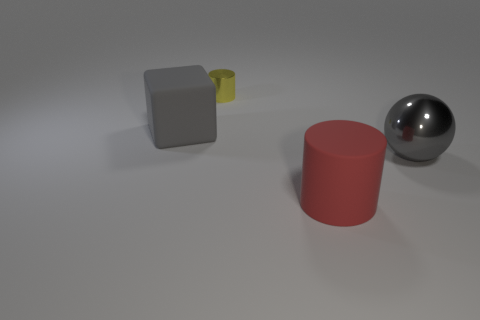Add 4 yellow shiny things. How many objects exist? 8 Subtract all cubes. How many objects are left? 3 Subtract 0 brown cubes. How many objects are left? 4 Subtract all brown cylinders. Subtract all purple blocks. How many cylinders are left? 2 Subtract all gray rubber cubes. Subtract all gray spheres. How many objects are left? 2 Add 2 red cylinders. How many red cylinders are left? 3 Add 1 large blue rubber cubes. How many large blue rubber cubes exist? 1 